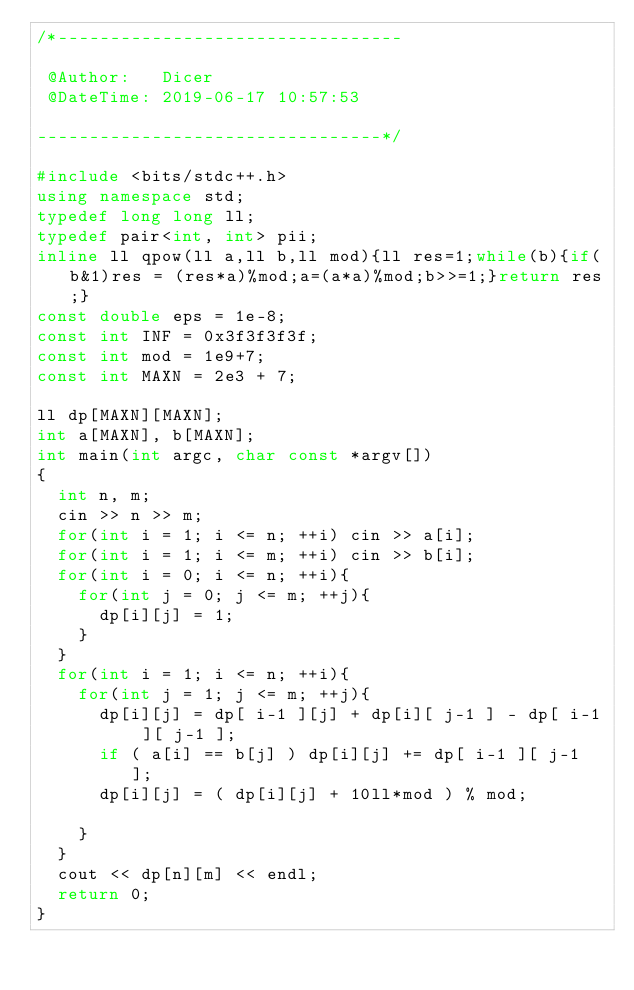<code> <loc_0><loc_0><loc_500><loc_500><_C++_>/*---------------------------------

 @Author:   Dicer
 @DateTime: 2019-06-17 10:57:53

---------------------------------*/

#include <bits/stdc++.h>
using namespace std;
typedef long long ll;
typedef pair<int, int> pii;
inline ll qpow(ll a,ll b,ll mod){ll res=1;while(b){if(b&1)res = (res*a)%mod;a=(a*a)%mod;b>>=1;}return res;}
const double eps = 1e-8;
const int INF = 0x3f3f3f3f;
const int mod = 1e9+7;
const int MAXN = 2e3 + 7;

ll dp[MAXN][MAXN];
int a[MAXN], b[MAXN];
int main(int argc, char const *argv[])
{	
	int n, m;
	cin >> n >> m;
	for(int i = 1; i <= n; ++i)	cin >> a[i];
	for(int i = 1; i <= m; ++i)	cin >> b[i];
	for(int i = 0; i <= n; ++i){
		for(int j = 0; j <= m; ++j){
			dp[i][j] = 1;
		}
	}
	for(int i = 1; i <= n; ++i){
		for(int j = 1; j <= m; ++j){
			dp[i][j] = dp[ i-1 ][j] + dp[i][ j-1 ] - dp[ i-1 ][ j-1 ];
			if ( a[i] == b[j] ) dp[i][j] += dp[ i-1 ][ j-1 ];
			dp[i][j] = ( dp[i][j] + 10ll*mod ) % mod;

		}
	}
	cout << dp[n][m] << endl;
	return 0;
}</code> 